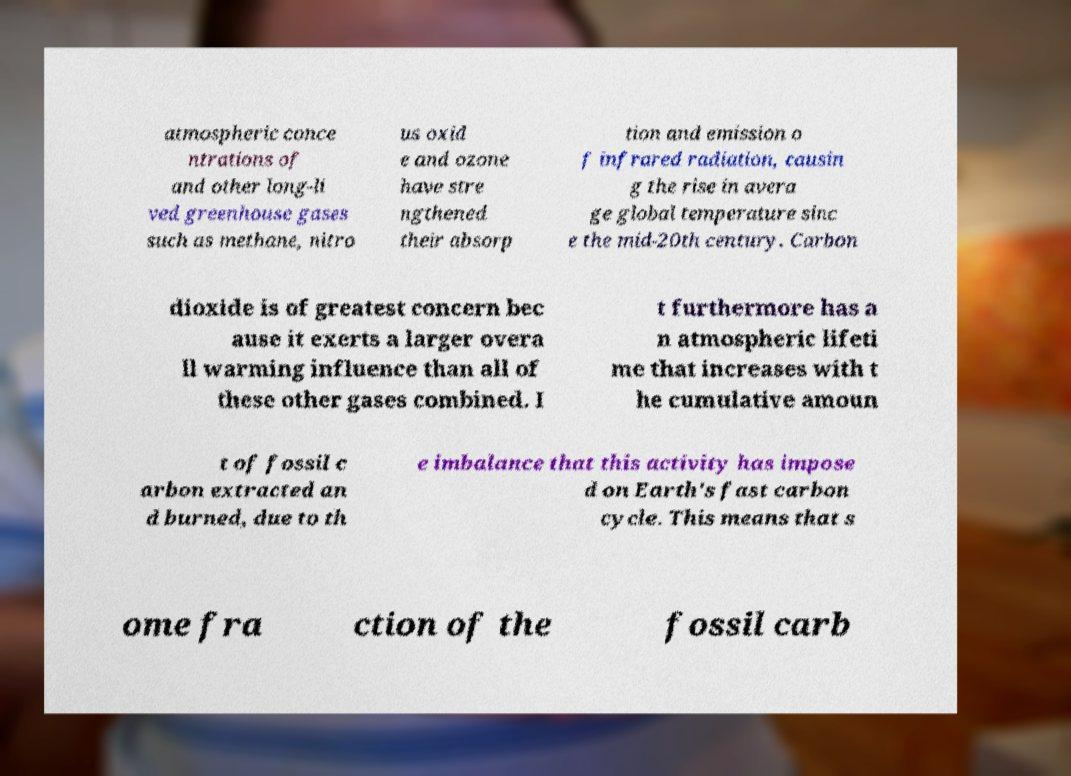Please read and relay the text visible in this image. What does it say? atmospheric conce ntrations of and other long-li ved greenhouse gases such as methane, nitro us oxid e and ozone have stre ngthened their absorp tion and emission o f infrared radiation, causin g the rise in avera ge global temperature sinc e the mid-20th century. Carbon dioxide is of greatest concern bec ause it exerts a larger overa ll warming influence than all of these other gases combined. I t furthermore has a n atmospheric lifeti me that increases with t he cumulative amoun t of fossil c arbon extracted an d burned, due to th e imbalance that this activity has impose d on Earth's fast carbon cycle. This means that s ome fra ction of the fossil carb 